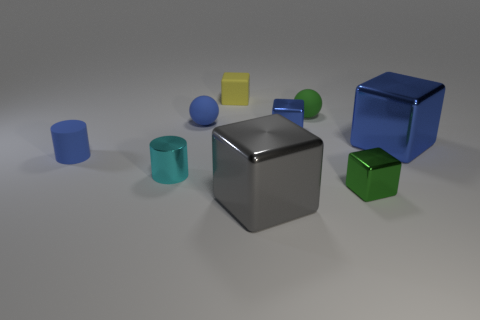What number of other objects are the same material as the small yellow cube?
Keep it short and to the point. 3. The small cylinder that is in front of the small thing that is left of the tiny cylinder in front of the small blue cylinder is what color?
Offer a very short reply. Cyan. There is a small matte thing that is behind the blue rubber ball and in front of the tiny yellow rubber thing; what is its shape?
Give a very brief answer. Sphere. There is a big cube left of the blue shiny cube on the left side of the green metallic block; what is its color?
Offer a terse response. Gray. There is a tiny metallic thing behind the cylinder on the right side of the cylinder to the left of the metallic cylinder; what shape is it?
Your answer should be very brief. Cube. There is a block that is both behind the big blue cube and in front of the tiny yellow thing; what is its size?
Make the answer very short. Small. How many tiny shiny blocks are the same color as the rubber cylinder?
Give a very brief answer. 1. What is the material of the tiny cube that is the same color as the rubber cylinder?
Make the answer very short. Metal. What is the blue cylinder made of?
Provide a succinct answer. Rubber. Do the sphere that is right of the small rubber block and the blue cylinder have the same material?
Provide a succinct answer. Yes. 